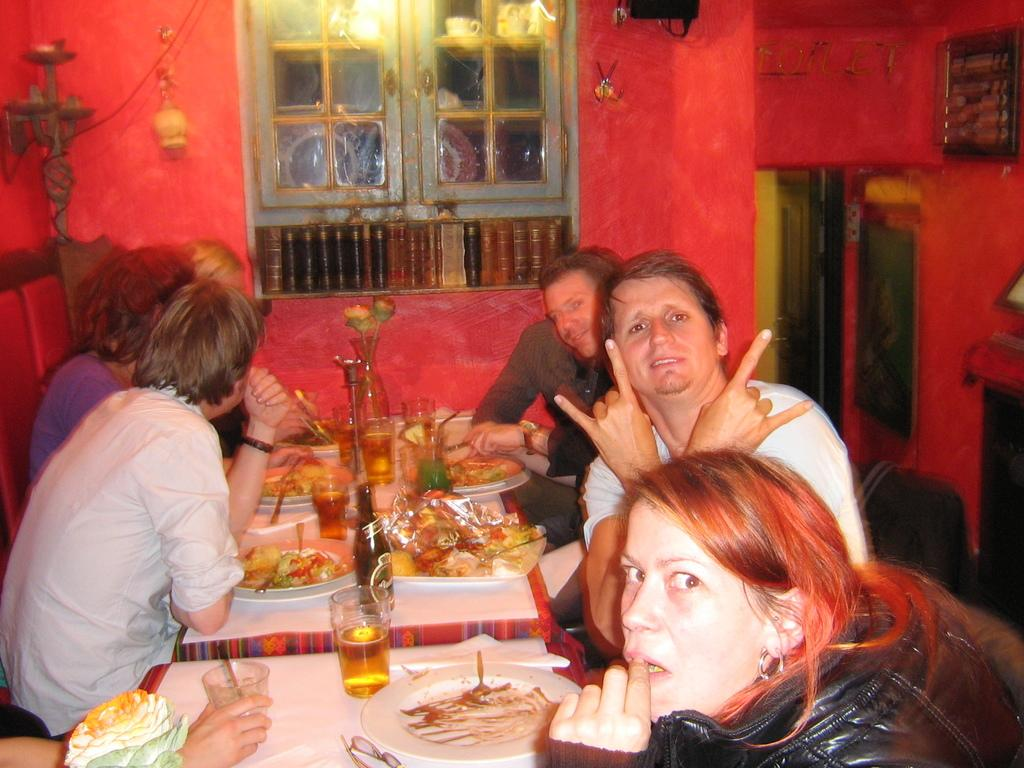How many people are in the image? There are several people in the image. What are the people doing in the image? The people are sitting at a table. What can be seen on the table besides the people? There are food items on the table. What is the color of the background in the image? The background color is red. Can you tell me how many dogs are sitting at the table with the people in the image? There are no dogs present in the image; only people are sitting at the table. What type of boundary can be seen separating the people from the background in the image? There is no boundary visible in the image; the people are sitting at a table in front of a red background. 